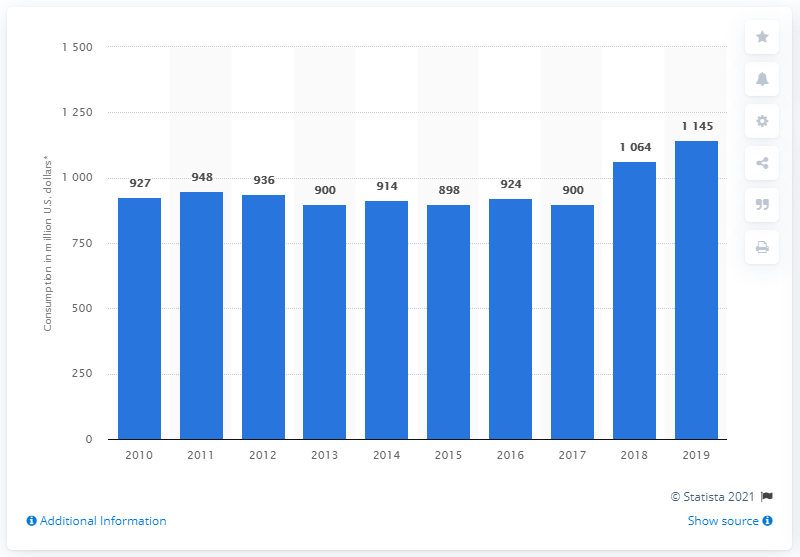Mention a couple of crucial points in this snapshot. A record of 900 million U.S dollars has been set, and it has been held for 2 years. 